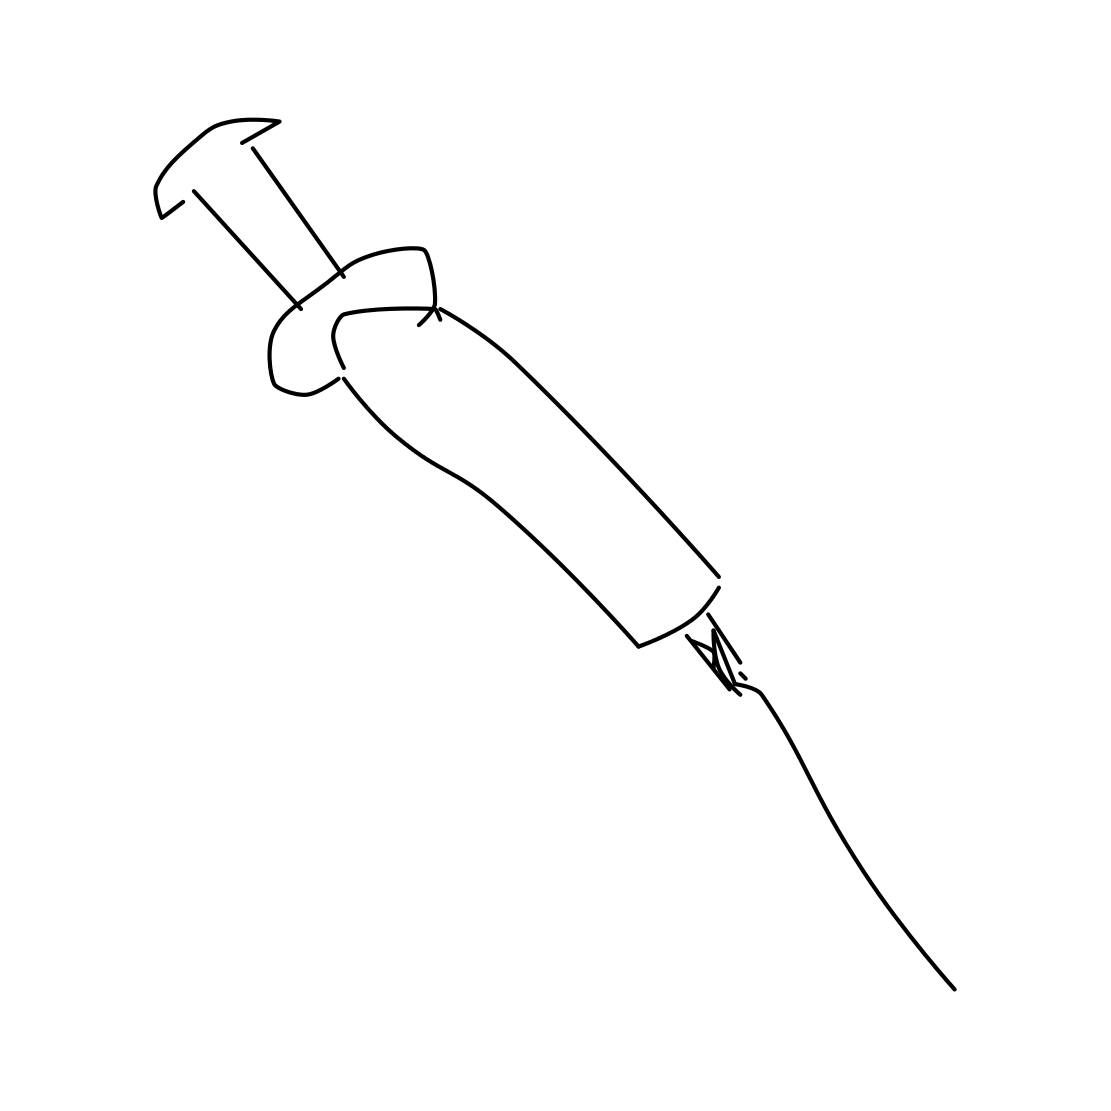What material does the syringe appear to be made of? The syringe in the image appears to be drawn with lines suggesting it could be made of plastic, a common material for modern disposable syringes. 